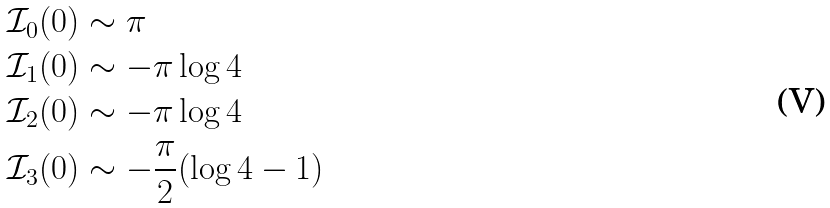Convert formula to latex. <formula><loc_0><loc_0><loc_500><loc_500>\mathcal { I } _ { 0 } ( 0 ) & \sim \pi \\ \mathcal { I } _ { 1 } ( 0 ) & \sim - \pi \log 4 \\ \mathcal { I } _ { 2 } ( 0 ) & \sim - \pi \log 4 \\ \mathcal { I } _ { 3 } ( 0 ) & \sim - \frac { \pi } { 2 } ( \log 4 - 1 )</formula> 